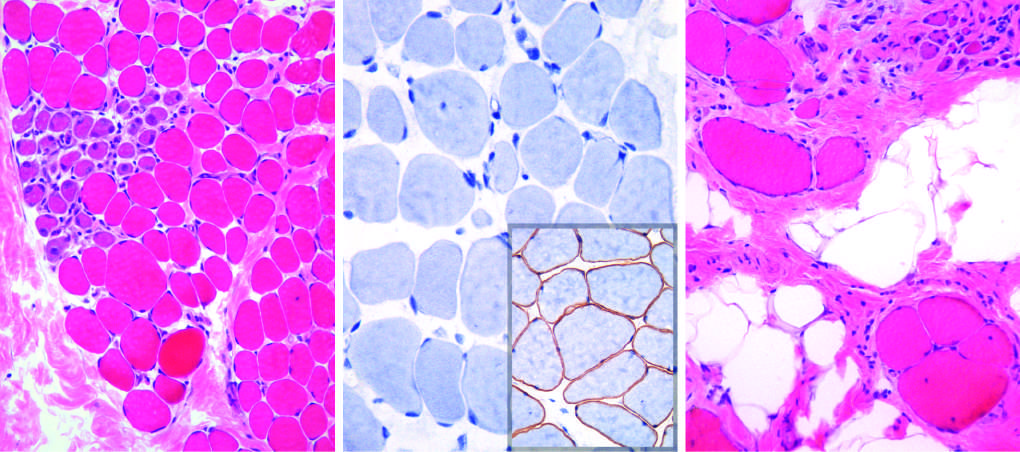s this abnormality stain in normal muscle seen?
Answer the question using a single word or phrase. No 